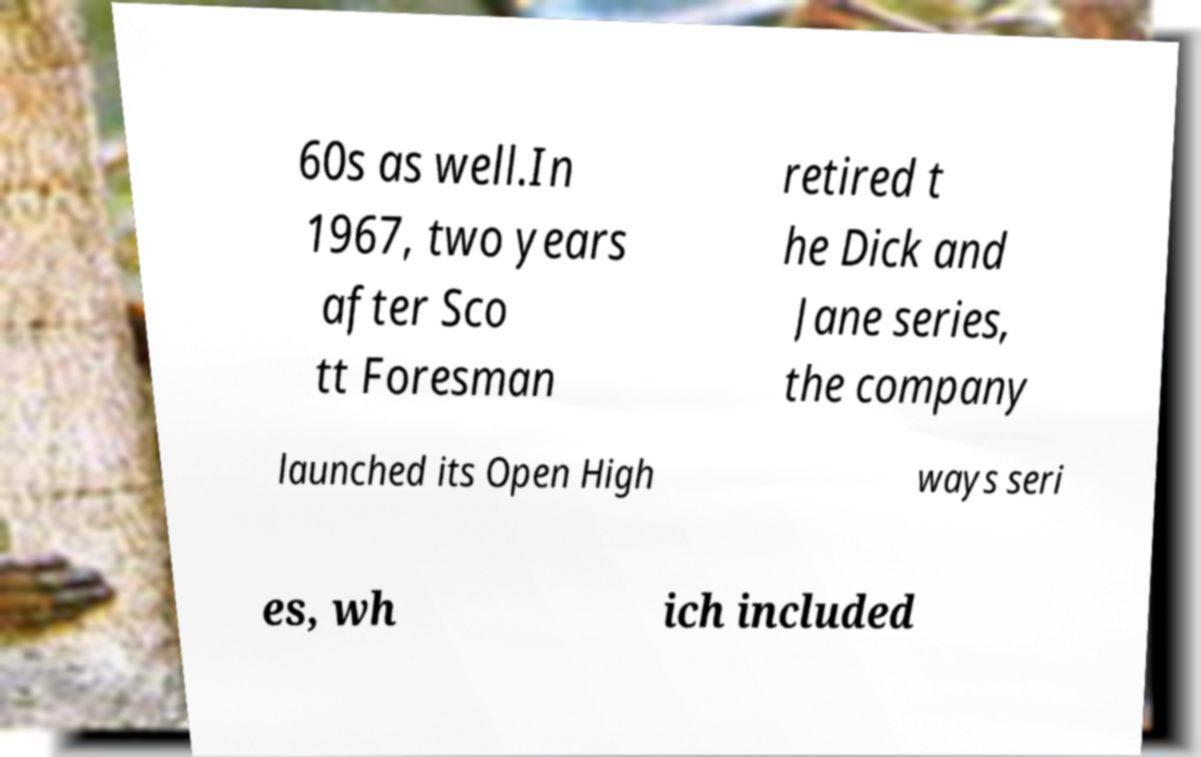There's text embedded in this image that I need extracted. Can you transcribe it verbatim? 60s as well.In 1967, two years after Sco tt Foresman retired t he Dick and Jane series, the company launched its Open High ways seri es, wh ich included 